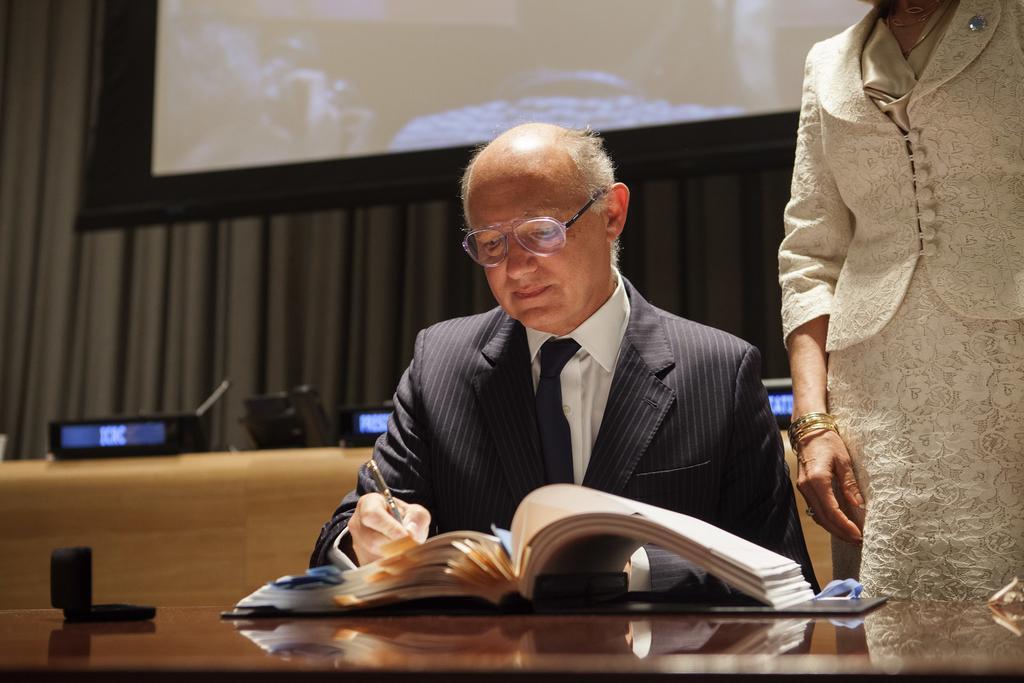In one or two sentences, can you explain what this image depicts? In the foreground of the picture there is a table, on the table there are book, box and a mat. In the center of the picture there is a person in black suit holding a pen. On the right there is a woman standing. In the background there are screens, mics, desk, curtain and a projector screen. 